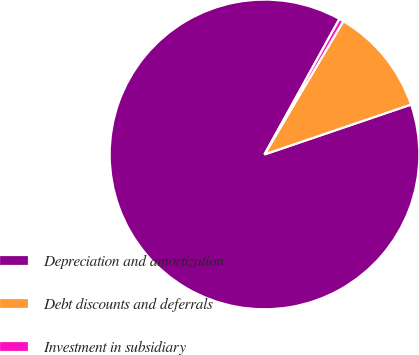Convert chart to OTSL. <chart><loc_0><loc_0><loc_500><loc_500><pie_chart><fcel>Depreciation and amortization<fcel>Debt discounts and deferrals<fcel>Investment in subsidiary<nl><fcel>88.26%<fcel>11.28%<fcel>0.46%<nl></chart> 